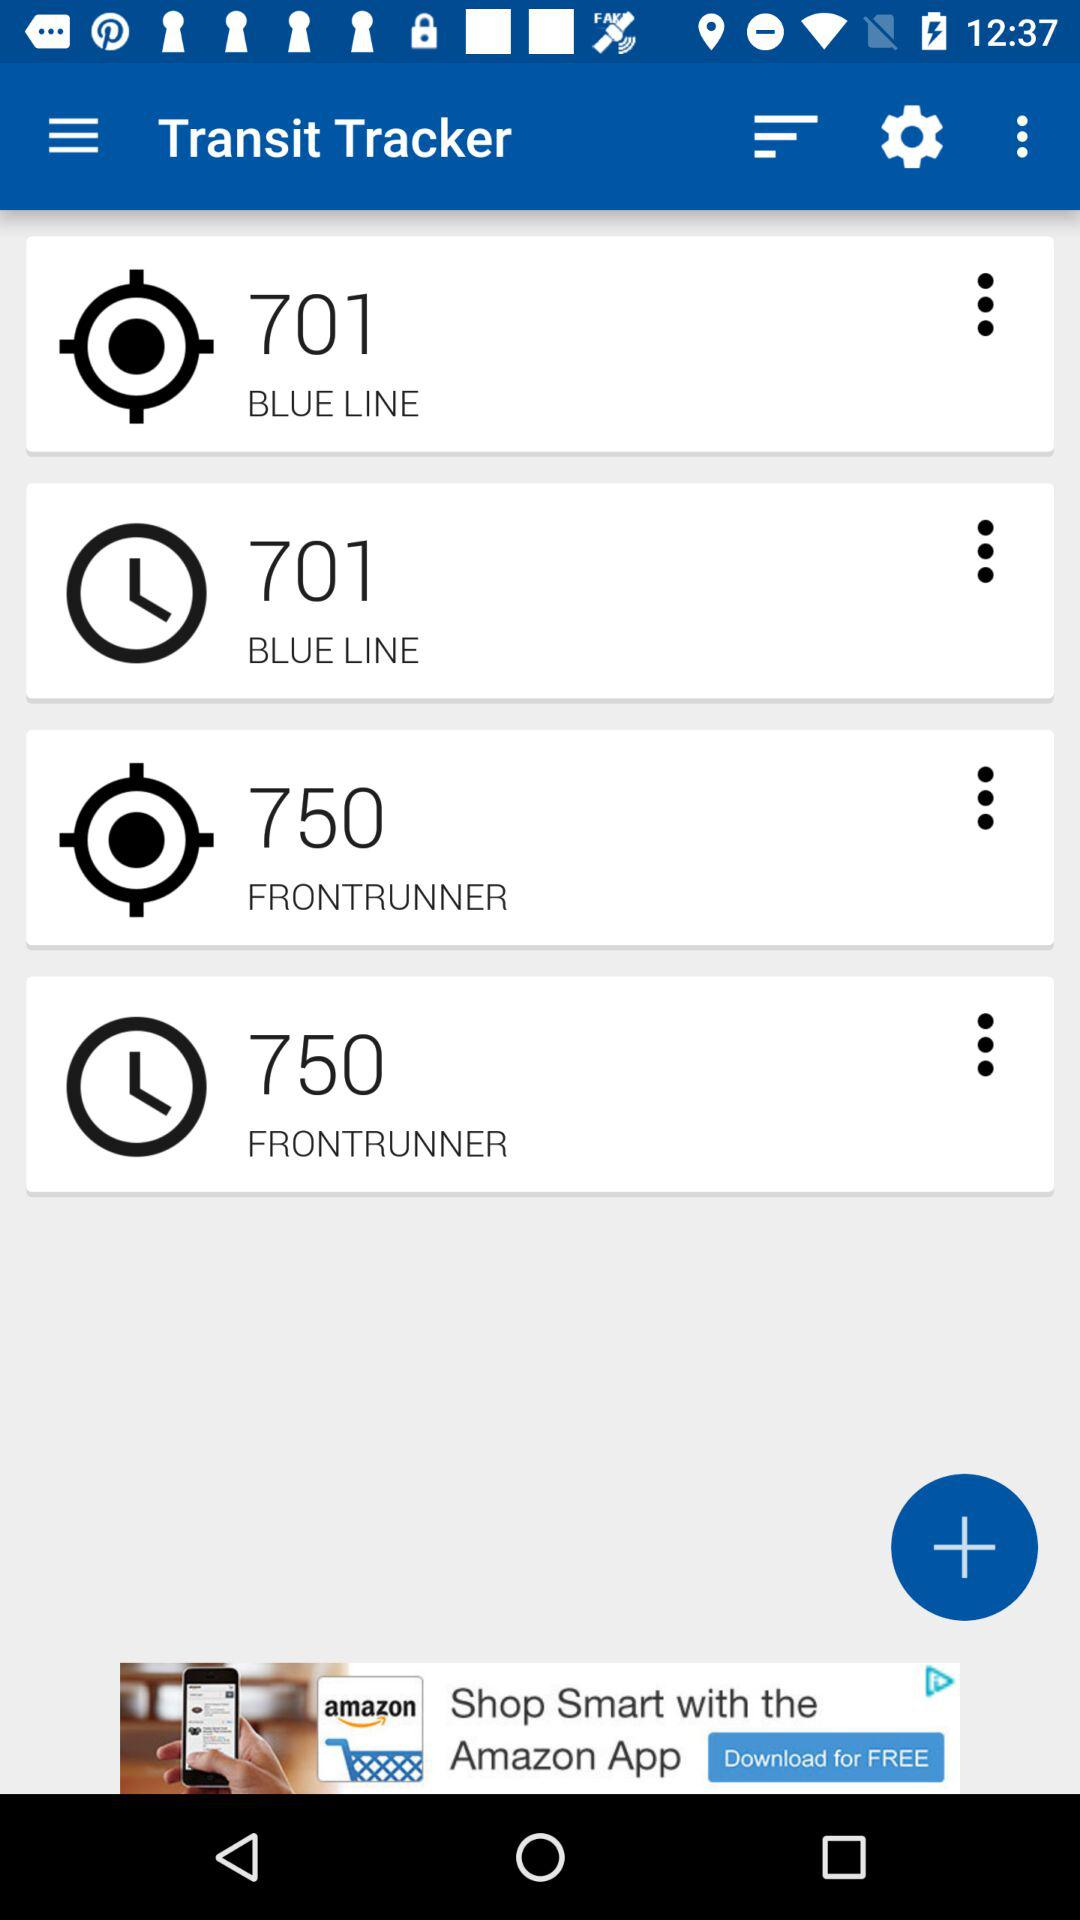What is the value of time for the blueline?
When the provided information is insufficient, respond with <no answer>. <no answer> 